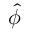Convert formula to latex. <formula><loc_0><loc_0><loc_500><loc_500>\hat { \phi }</formula> 